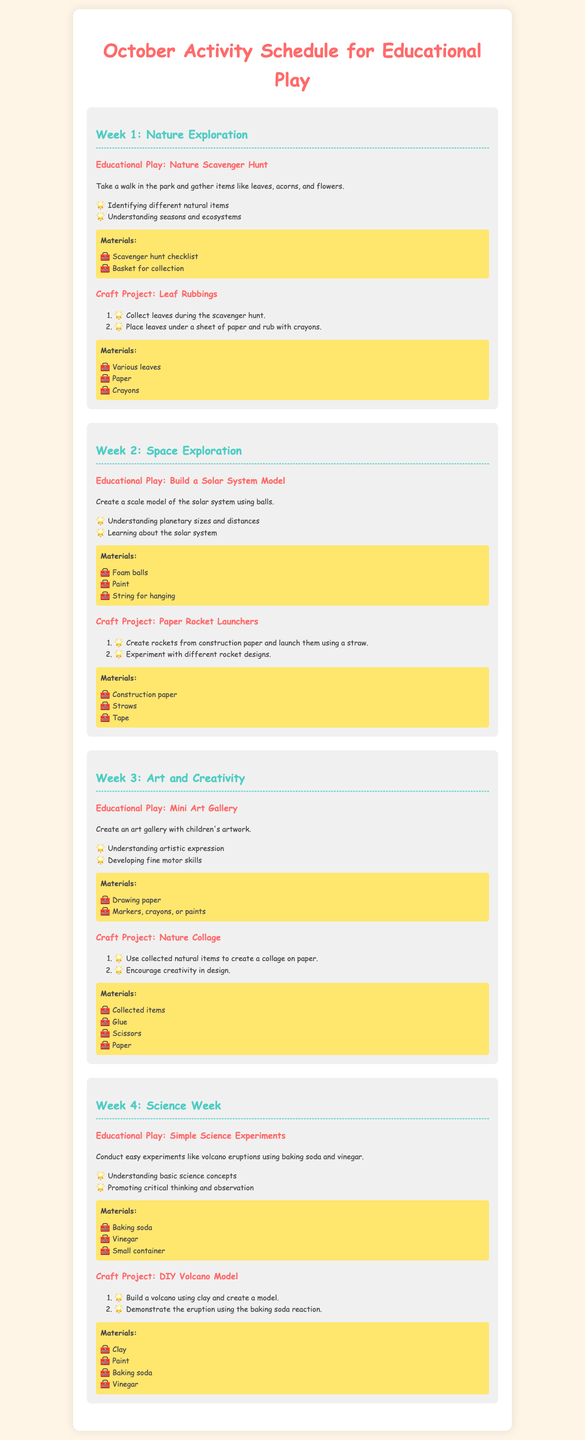What is the title of the document? The title is displayed prominently at the top of the document, stating what the schedule is for.
Answer: October Activity Schedule for Educational Play How many weeks are covered in the schedule? Each week is distinctly labeled in the document, showing that there are four weeks.
Answer: 4 What is the first educational play activity listed? The first activity is highlighted under Week 1, specifying the focus of that week.
Answer: Nature Scavenger Hunt What materials are needed for the Leaf Rubbings craft? The materials for the craft under Week 1 are listed for easy reference.
Answer: Various leaves, Paper, Crayons Which week focuses on "Space Exploration"? The document specifies themes for each week, clearly indicating the subject of Week 2.
Answer: Week 2 What type of experiment is suggested in Week 4? The document outlines the nature of the educational play for science week, explaining the type of experiments conducted.
Answer: Simple Science Experiments What is one key learning objective of the Space Exploration week? The objectives are summarized in bullet points under the educational play section for each week.
Answer: Learning about the solar system What is the craft project for Week 3? The craft project is mentioned alongside the educational play for each week, indicating the activity planned.
Answer: Nature Collage 